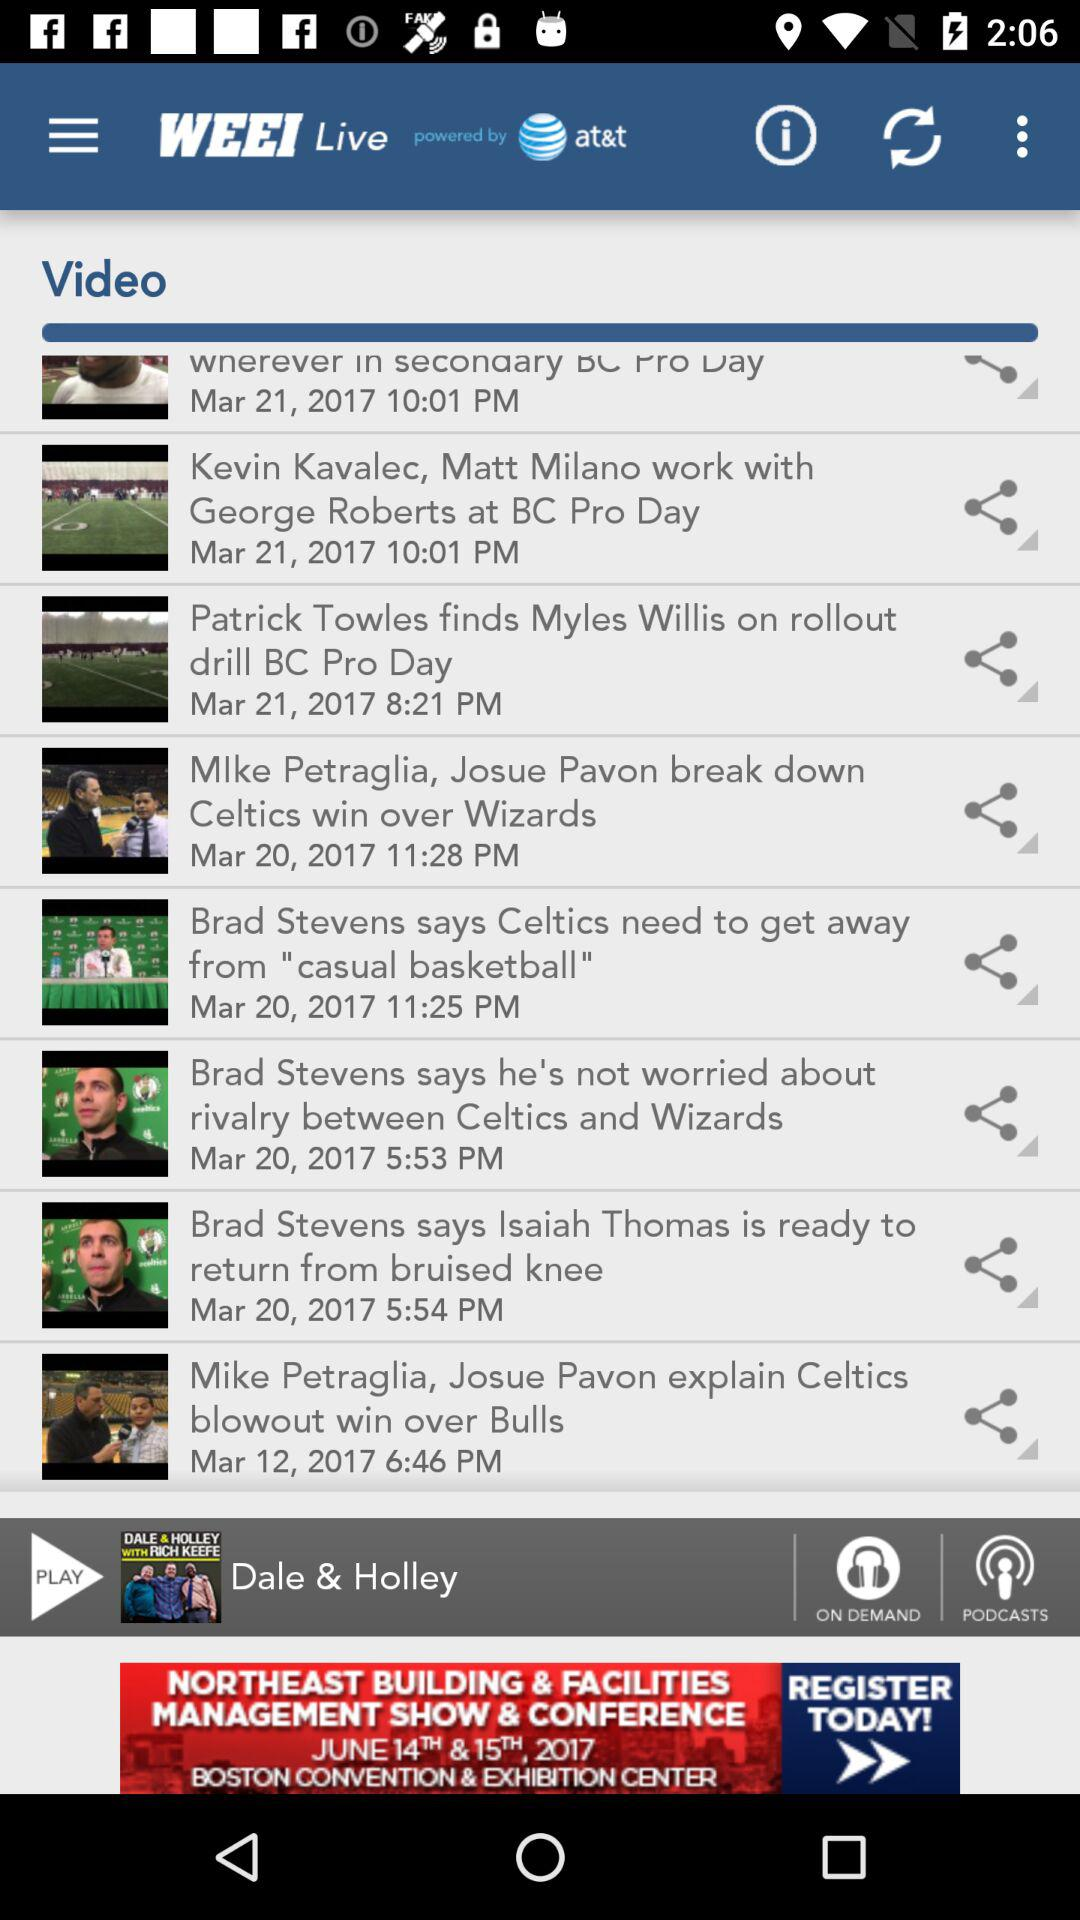By whom is "WEEI Live" powered? "WEEI Live" is powered by "at&t". 